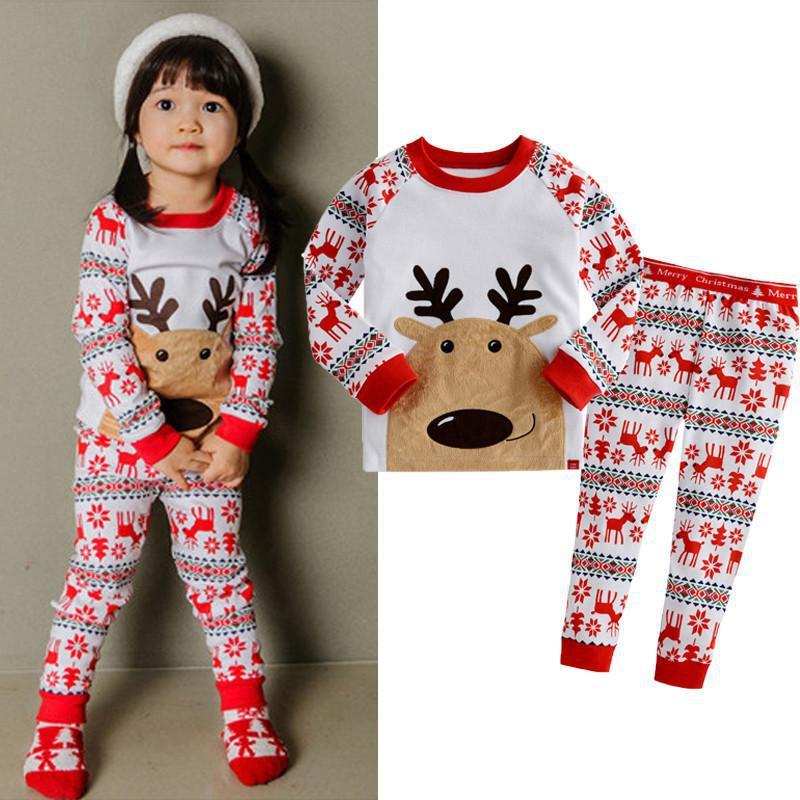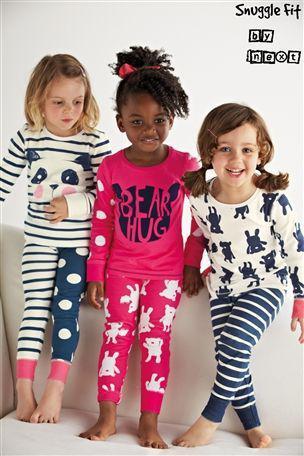The first image is the image on the left, the second image is the image on the right. For the images shown, is this caption "There are more kids in the image on the right than in the image on the left." true? Answer yes or no. Yes. The first image is the image on the left, the second image is the image on the right. Examine the images to the left and right. Is the description "One image shows two sleepwear outfits that feature the face of a Disney princess-type character on the front." accurate? Answer yes or no. No. 